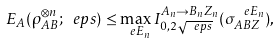<formula> <loc_0><loc_0><loc_500><loc_500>E _ { A } ( \rho _ { A B } ^ { \otimes n } ; \ e p s ) \leq \max _ { \ e E _ { n } } I ^ { A _ { n } \to B _ { n } Z _ { n } } _ { 0 , 2 \sqrt { \ e p s } } ( \sigma _ { A B Z } ^ { \ e E _ { n } } ) ,</formula> 